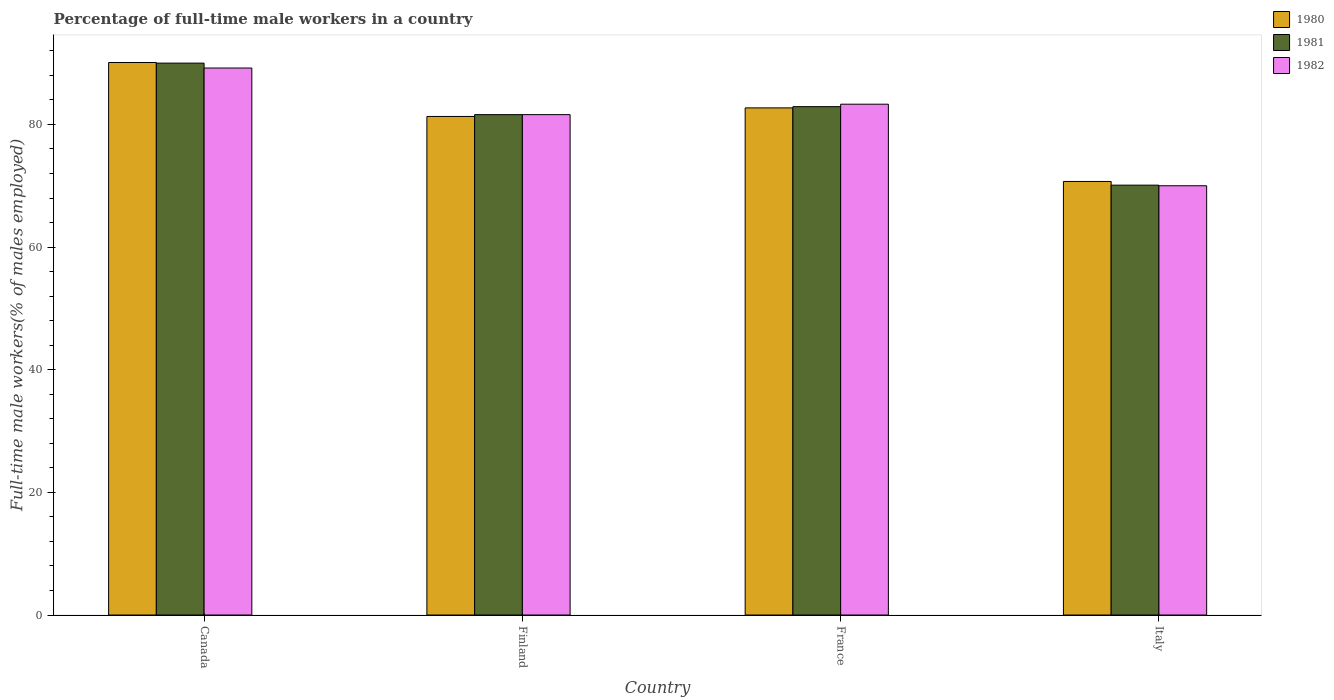How many different coloured bars are there?
Make the answer very short. 3. What is the percentage of full-time male workers in 1982 in Canada?
Offer a terse response. 89.2. Across all countries, what is the maximum percentage of full-time male workers in 1982?
Keep it short and to the point. 89.2. Across all countries, what is the minimum percentage of full-time male workers in 1981?
Provide a short and direct response. 70.1. In which country was the percentage of full-time male workers in 1982 maximum?
Make the answer very short. Canada. In which country was the percentage of full-time male workers in 1981 minimum?
Offer a terse response. Italy. What is the total percentage of full-time male workers in 1982 in the graph?
Make the answer very short. 324.1. What is the difference between the percentage of full-time male workers in 1982 in Finland and that in Italy?
Provide a succinct answer. 11.6. What is the difference between the percentage of full-time male workers in 1982 in Canada and the percentage of full-time male workers in 1980 in Finland?
Provide a succinct answer. 7.9. What is the average percentage of full-time male workers in 1980 per country?
Your response must be concise. 81.2. What is the difference between the percentage of full-time male workers of/in 1981 and percentage of full-time male workers of/in 1982 in Finland?
Keep it short and to the point. 0. In how many countries, is the percentage of full-time male workers in 1981 greater than 72 %?
Ensure brevity in your answer.  3. What is the ratio of the percentage of full-time male workers in 1981 in France to that in Italy?
Offer a very short reply. 1.18. Is the difference between the percentage of full-time male workers in 1981 in Canada and Finland greater than the difference between the percentage of full-time male workers in 1982 in Canada and Finland?
Make the answer very short. Yes. What is the difference between the highest and the second highest percentage of full-time male workers in 1982?
Give a very brief answer. -7.6. What is the difference between the highest and the lowest percentage of full-time male workers in 1982?
Offer a very short reply. 19.2. In how many countries, is the percentage of full-time male workers in 1980 greater than the average percentage of full-time male workers in 1980 taken over all countries?
Your response must be concise. 3. What does the 3rd bar from the left in Canada represents?
Your answer should be compact. 1982. Is it the case that in every country, the sum of the percentage of full-time male workers in 1980 and percentage of full-time male workers in 1982 is greater than the percentage of full-time male workers in 1981?
Your response must be concise. Yes. Are all the bars in the graph horizontal?
Provide a succinct answer. No. How many countries are there in the graph?
Ensure brevity in your answer.  4. Are the values on the major ticks of Y-axis written in scientific E-notation?
Offer a very short reply. No. Does the graph contain any zero values?
Provide a short and direct response. No. Where does the legend appear in the graph?
Give a very brief answer. Top right. How many legend labels are there?
Ensure brevity in your answer.  3. How are the legend labels stacked?
Your answer should be compact. Vertical. What is the title of the graph?
Keep it short and to the point. Percentage of full-time male workers in a country. Does "2005" appear as one of the legend labels in the graph?
Provide a succinct answer. No. What is the label or title of the Y-axis?
Offer a very short reply. Full-time male workers(% of males employed). What is the Full-time male workers(% of males employed) in 1980 in Canada?
Keep it short and to the point. 90.1. What is the Full-time male workers(% of males employed) of 1982 in Canada?
Ensure brevity in your answer.  89.2. What is the Full-time male workers(% of males employed) of 1980 in Finland?
Make the answer very short. 81.3. What is the Full-time male workers(% of males employed) in 1981 in Finland?
Your response must be concise. 81.6. What is the Full-time male workers(% of males employed) in 1982 in Finland?
Provide a short and direct response. 81.6. What is the Full-time male workers(% of males employed) of 1980 in France?
Offer a terse response. 82.7. What is the Full-time male workers(% of males employed) in 1981 in France?
Provide a succinct answer. 82.9. What is the Full-time male workers(% of males employed) of 1982 in France?
Provide a succinct answer. 83.3. What is the Full-time male workers(% of males employed) of 1980 in Italy?
Keep it short and to the point. 70.7. What is the Full-time male workers(% of males employed) in 1981 in Italy?
Your answer should be very brief. 70.1. Across all countries, what is the maximum Full-time male workers(% of males employed) in 1980?
Ensure brevity in your answer.  90.1. Across all countries, what is the maximum Full-time male workers(% of males employed) of 1981?
Keep it short and to the point. 90. Across all countries, what is the maximum Full-time male workers(% of males employed) of 1982?
Provide a succinct answer. 89.2. Across all countries, what is the minimum Full-time male workers(% of males employed) in 1980?
Give a very brief answer. 70.7. Across all countries, what is the minimum Full-time male workers(% of males employed) in 1981?
Offer a terse response. 70.1. What is the total Full-time male workers(% of males employed) of 1980 in the graph?
Your response must be concise. 324.8. What is the total Full-time male workers(% of males employed) of 1981 in the graph?
Your response must be concise. 324.6. What is the total Full-time male workers(% of males employed) in 1982 in the graph?
Provide a short and direct response. 324.1. What is the difference between the Full-time male workers(% of males employed) of 1980 in Canada and that in France?
Ensure brevity in your answer.  7.4. What is the difference between the Full-time male workers(% of males employed) of 1980 in Canada and that in Italy?
Keep it short and to the point. 19.4. What is the difference between the Full-time male workers(% of males employed) of 1981 in Canada and that in Italy?
Your answer should be very brief. 19.9. What is the difference between the Full-time male workers(% of males employed) of 1982 in Canada and that in Italy?
Keep it short and to the point. 19.2. What is the difference between the Full-time male workers(% of males employed) in 1980 in Finland and that in France?
Provide a succinct answer. -1.4. What is the difference between the Full-time male workers(% of males employed) of 1981 in Finland and that in France?
Provide a succinct answer. -1.3. What is the difference between the Full-time male workers(% of males employed) of 1980 in Finland and that in Italy?
Your response must be concise. 10.6. What is the difference between the Full-time male workers(% of males employed) in 1981 in Finland and that in Italy?
Your answer should be very brief. 11.5. What is the difference between the Full-time male workers(% of males employed) of 1980 in France and that in Italy?
Provide a succinct answer. 12. What is the difference between the Full-time male workers(% of males employed) of 1981 in France and that in Italy?
Provide a short and direct response. 12.8. What is the difference between the Full-time male workers(% of males employed) of 1982 in France and that in Italy?
Give a very brief answer. 13.3. What is the difference between the Full-time male workers(% of males employed) in 1980 in Canada and the Full-time male workers(% of males employed) in 1982 in Finland?
Your answer should be very brief. 8.5. What is the difference between the Full-time male workers(% of males employed) in 1981 in Canada and the Full-time male workers(% of males employed) in 1982 in Finland?
Offer a terse response. 8.4. What is the difference between the Full-time male workers(% of males employed) in 1980 in Canada and the Full-time male workers(% of males employed) in 1982 in France?
Keep it short and to the point. 6.8. What is the difference between the Full-time male workers(% of males employed) in 1980 in Canada and the Full-time male workers(% of males employed) in 1982 in Italy?
Offer a terse response. 20.1. What is the difference between the Full-time male workers(% of males employed) in 1981 in Canada and the Full-time male workers(% of males employed) in 1982 in Italy?
Your answer should be very brief. 20. What is the difference between the Full-time male workers(% of males employed) in 1981 in Finland and the Full-time male workers(% of males employed) in 1982 in France?
Provide a succinct answer. -1.7. What is the difference between the Full-time male workers(% of males employed) of 1980 in Finland and the Full-time male workers(% of males employed) of 1982 in Italy?
Offer a terse response. 11.3. What is the difference between the Full-time male workers(% of males employed) of 1981 in Finland and the Full-time male workers(% of males employed) of 1982 in Italy?
Your answer should be very brief. 11.6. What is the difference between the Full-time male workers(% of males employed) of 1980 in France and the Full-time male workers(% of males employed) of 1981 in Italy?
Ensure brevity in your answer.  12.6. What is the difference between the Full-time male workers(% of males employed) in 1980 in France and the Full-time male workers(% of males employed) in 1982 in Italy?
Offer a very short reply. 12.7. What is the difference between the Full-time male workers(% of males employed) in 1981 in France and the Full-time male workers(% of males employed) in 1982 in Italy?
Offer a terse response. 12.9. What is the average Full-time male workers(% of males employed) in 1980 per country?
Your response must be concise. 81.2. What is the average Full-time male workers(% of males employed) of 1981 per country?
Provide a succinct answer. 81.15. What is the average Full-time male workers(% of males employed) of 1982 per country?
Keep it short and to the point. 81.03. What is the difference between the Full-time male workers(% of males employed) of 1980 and Full-time male workers(% of males employed) of 1982 in Canada?
Provide a succinct answer. 0.9. What is the difference between the Full-time male workers(% of males employed) in 1981 and Full-time male workers(% of males employed) in 1982 in Canada?
Give a very brief answer. 0.8. What is the difference between the Full-time male workers(% of males employed) in 1980 and Full-time male workers(% of males employed) in 1982 in Finland?
Provide a succinct answer. -0.3. What is the difference between the Full-time male workers(% of males employed) of 1980 and Full-time male workers(% of males employed) of 1981 in France?
Keep it short and to the point. -0.2. What is the difference between the Full-time male workers(% of males employed) in 1980 and Full-time male workers(% of males employed) in 1982 in France?
Keep it short and to the point. -0.6. What is the difference between the Full-time male workers(% of males employed) of 1981 and Full-time male workers(% of males employed) of 1982 in France?
Your answer should be very brief. -0.4. What is the difference between the Full-time male workers(% of males employed) of 1980 and Full-time male workers(% of males employed) of 1981 in Italy?
Provide a short and direct response. 0.6. What is the difference between the Full-time male workers(% of males employed) in 1980 and Full-time male workers(% of males employed) in 1982 in Italy?
Offer a terse response. 0.7. What is the ratio of the Full-time male workers(% of males employed) in 1980 in Canada to that in Finland?
Ensure brevity in your answer.  1.11. What is the ratio of the Full-time male workers(% of males employed) in 1981 in Canada to that in Finland?
Ensure brevity in your answer.  1.1. What is the ratio of the Full-time male workers(% of males employed) in 1982 in Canada to that in Finland?
Offer a very short reply. 1.09. What is the ratio of the Full-time male workers(% of males employed) in 1980 in Canada to that in France?
Make the answer very short. 1.09. What is the ratio of the Full-time male workers(% of males employed) of 1981 in Canada to that in France?
Your response must be concise. 1.09. What is the ratio of the Full-time male workers(% of males employed) of 1982 in Canada to that in France?
Your answer should be compact. 1.07. What is the ratio of the Full-time male workers(% of males employed) of 1980 in Canada to that in Italy?
Your response must be concise. 1.27. What is the ratio of the Full-time male workers(% of males employed) in 1981 in Canada to that in Italy?
Your response must be concise. 1.28. What is the ratio of the Full-time male workers(% of males employed) in 1982 in Canada to that in Italy?
Make the answer very short. 1.27. What is the ratio of the Full-time male workers(% of males employed) in 1980 in Finland to that in France?
Your answer should be compact. 0.98. What is the ratio of the Full-time male workers(% of males employed) in 1981 in Finland to that in France?
Your answer should be very brief. 0.98. What is the ratio of the Full-time male workers(% of males employed) of 1982 in Finland to that in France?
Provide a succinct answer. 0.98. What is the ratio of the Full-time male workers(% of males employed) in 1980 in Finland to that in Italy?
Your answer should be compact. 1.15. What is the ratio of the Full-time male workers(% of males employed) in 1981 in Finland to that in Italy?
Give a very brief answer. 1.16. What is the ratio of the Full-time male workers(% of males employed) in 1982 in Finland to that in Italy?
Give a very brief answer. 1.17. What is the ratio of the Full-time male workers(% of males employed) of 1980 in France to that in Italy?
Give a very brief answer. 1.17. What is the ratio of the Full-time male workers(% of males employed) in 1981 in France to that in Italy?
Make the answer very short. 1.18. What is the ratio of the Full-time male workers(% of males employed) in 1982 in France to that in Italy?
Give a very brief answer. 1.19. What is the difference between the highest and the second highest Full-time male workers(% of males employed) in 1980?
Your answer should be very brief. 7.4. What is the difference between the highest and the second highest Full-time male workers(% of males employed) of 1981?
Your answer should be compact. 7.1. What is the difference between the highest and the second highest Full-time male workers(% of males employed) of 1982?
Provide a short and direct response. 5.9. What is the difference between the highest and the lowest Full-time male workers(% of males employed) of 1981?
Your response must be concise. 19.9. 